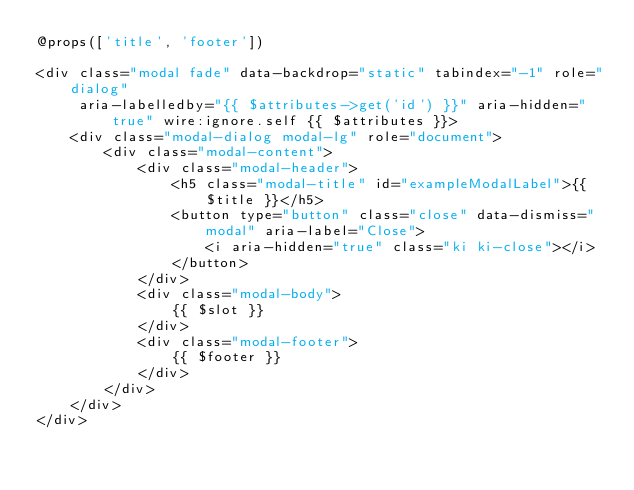<code> <loc_0><loc_0><loc_500><loc_500><_PHP_>@props(['title', 'footer'])

<div class="modal fade" data-backdrop="static" tabindex="-1" role="dialog"
     aria-labelledby="{{ $attributes->get('id') }}" aria-hidden="true" wire:ignore.self {{ $attributes }}>
    <div class="modal-dialog modal-lg" role="document">
        <div class="modal-content">
            <div class="modal-header">
                <h5 class="modal-title" id="exampleModalLabel">{{ $title }}</h5>
                <button type="button" class="close" data-dismiss="modal" aria-label="Close">
                    <i aria-hidden="true" class="ki ki-close"></i>
                </button>
            </div>
            <div class="modal-body">
                {{ $slot }}
            </div>
            <div class="modal-footer">
                {{ $footer }}
            </div>
        </div>
    </div>
</div>
</code> 